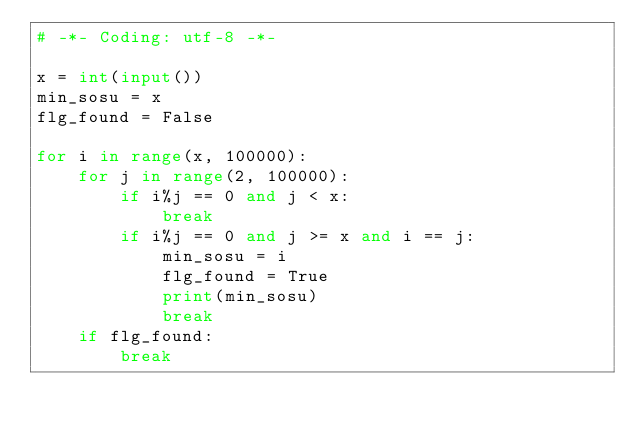<code> <loc_0><loc_0><loc_500><loc_500><_Python_># -*- Coding: utf-8 -*-

x = int(input())
min_sosu = x
flg_found = False

for i in range(x, 100000):
    for j in range(2, 100000):
        if i%j == 0 and j < x:
            break
        if i%j == 0 and j >= x and i == j:
            min_sosu = i
            flg_found = True
            print(min_sosu)
            break
    if flg_found:
        break
</code> 